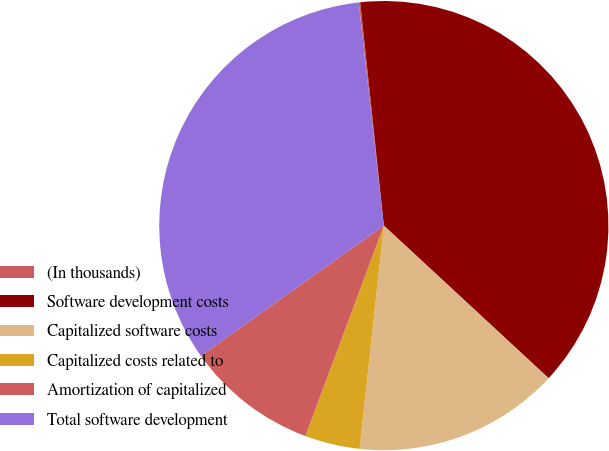<chart> <loc_0><loc_0><loc_500><loc_500><pie_chart><fcel>(In thousands)<fcel>Software development costs<fcel>Capitalized software costs<fcel>Capitalized costs related to<fcel>Amortization of capitalized<fcel>Total software development<nl><fcel>0.11%<fcel>38.57%<fcel>14.83%<fcel>3.96%<fcel>9.47%<fcel>33.06%<nl></chart> 